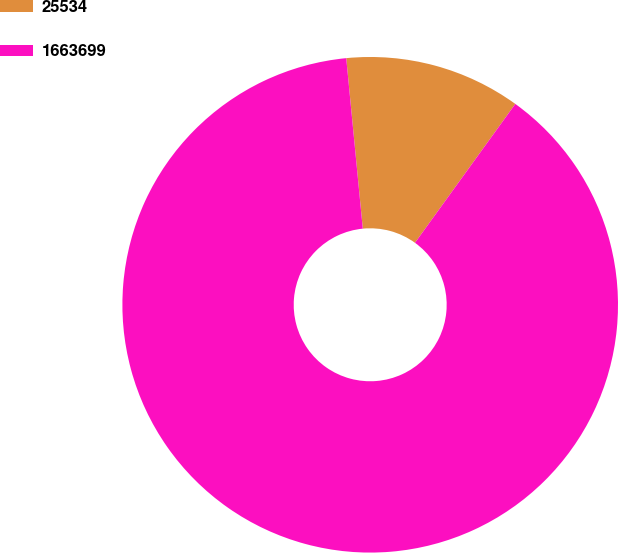<chart> <loc_0><loc_0><loc_500><loc_500><pie_chart><fcel>25534<fcel>1663699<nl><fcel>11.5%<fcel>88.5%<nl></chart> 